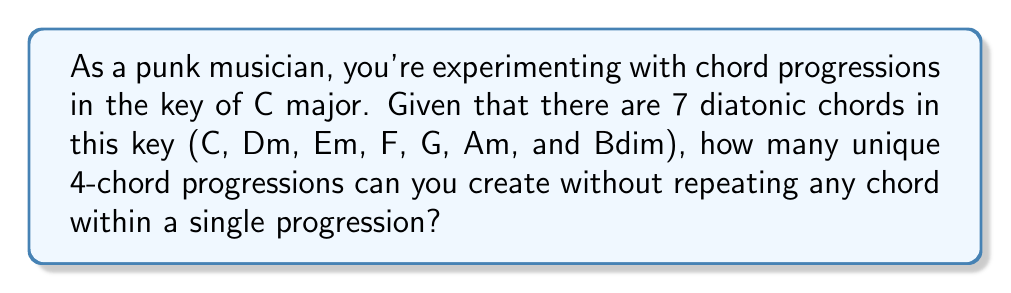Teach me how to tackle this problem. To solve this problem, we need to use the concept of permutations without repetition. Here's how we can approach it:

1. We have 7 chords to choose from for each position in our 4-chord progression.
2. For the first chord, we have 7 choices.
3. For the second chord, we have 6 choices (since we can't repeat the first chord).
4. For the third chord, we have 5 choices.
5. For the fourth chord, we have 4 choices.

This scenario is a perfect setup for the permutation formula:

$$ P(n,r) = \frac{n!}{(n-r)!} $$

Where $n$ is the total number of items to choose from (7 chords), and $r$ is the number of items being chosen (4 chords in our progression).

Plugging in our values:

$$ P(7,4) = \frac{7!}{(7-4)!} = \frac{7!}{3!} $$

Expanding this:

$$ \frac{7 \times 6 \times 5 \times 4 \times 3!}{3!} $$

The $3!$ cancels out in the numerator and denominator:

$$ 7 \times 6 \times 5 \times 4 = 840 $$

Therefore, there are 840 unique 4-chord progressions possible using the diatonic chords in the key of C major without repetition.
Answer: 840 unique 4-chord progressions 